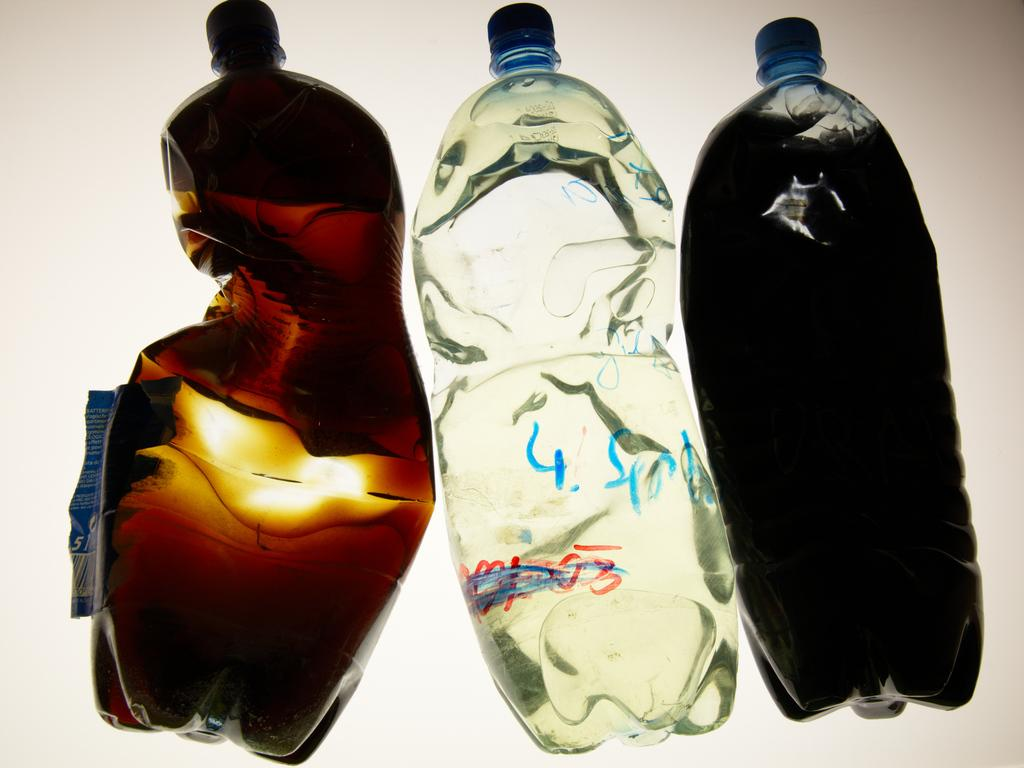How many water bottles are visible in the image? There are three water bottles in the image. What is the condition of the water bottles? The water bottles are crushed. What type of pancake is being served on the plate in the image? There is no plate or pancake present in the image; it only features crushed water bottles. 